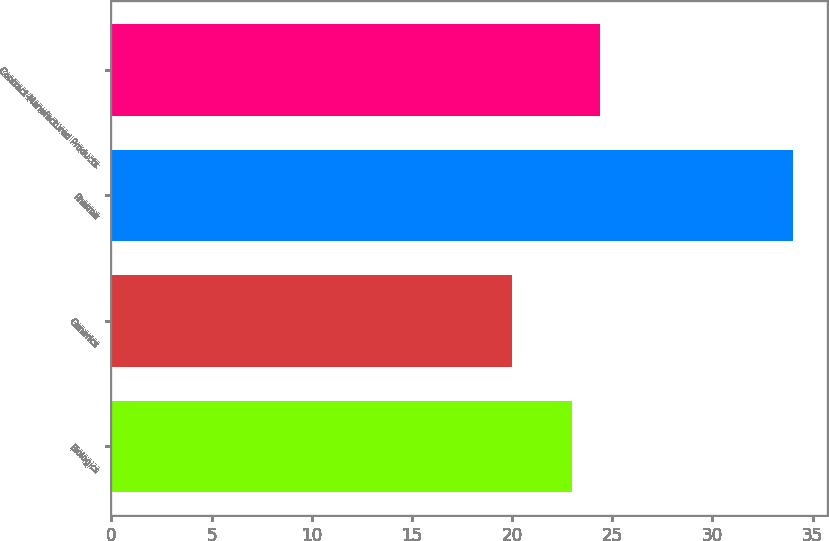Convert chart to OTSL. <chart><loc_0><loc_0><loc_500><loc_500><bar_chart><fcel>Biologics<fcel>Generics<fcel>Pharma<fcel>Contract-Manufactured Products<nl><fcel>23<fcel>20<fcel>34<fcel>24.4<nl></chart> 